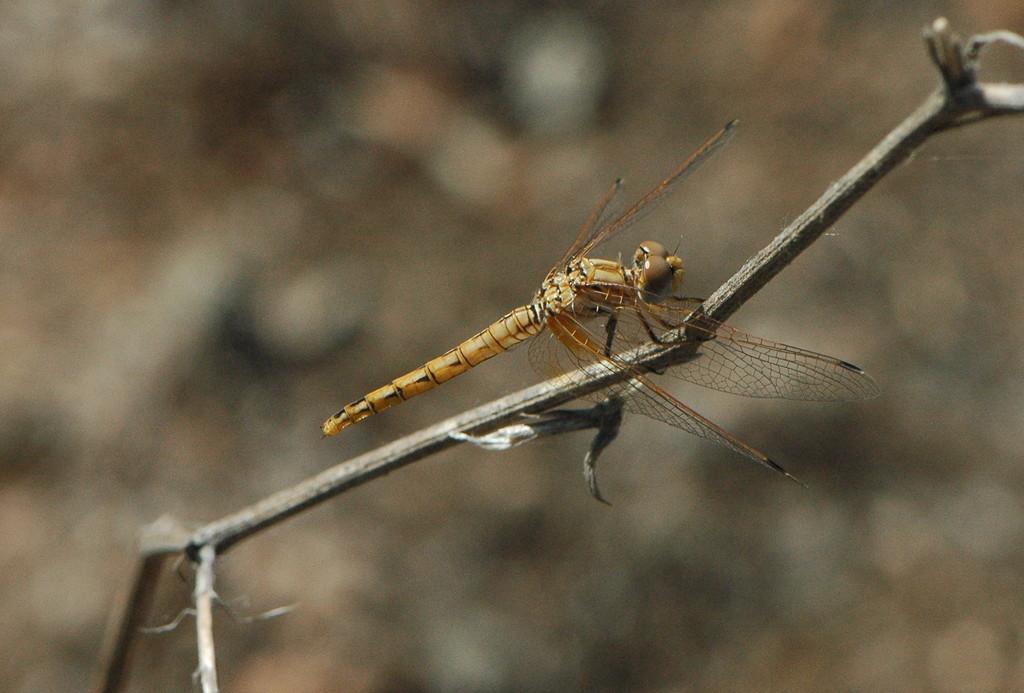Please provide a concise description of this image. In this image, we can see a fly on the stem and the background is blurry. 